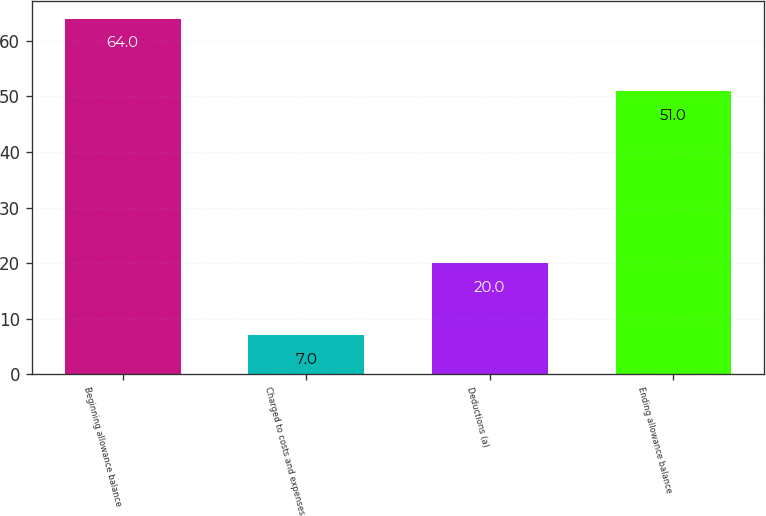Convert chart. <chart><loc_0><loc_0><loc_500><loc_500><bar_chart><fcel>Beginning allowance balance<fcel>Charged to costs and expenses<fcel>Deductions (a)<fcel>Ending allowance balance<nl><fcel>64<fcel>7<fcel>20<fcel>51<nl></chart> 